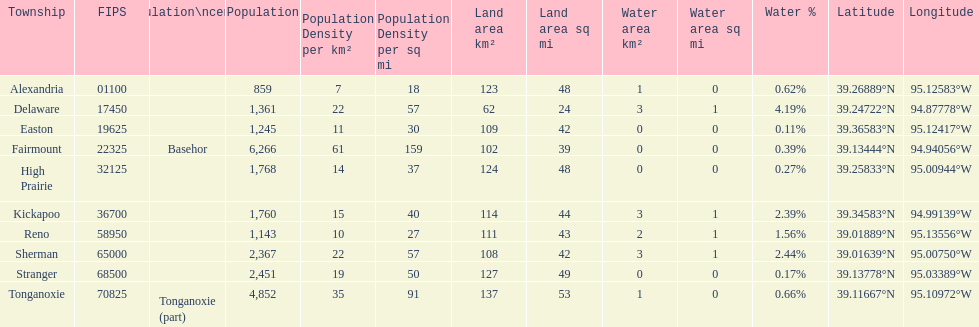How many townships are in leavenworth county? 10. 